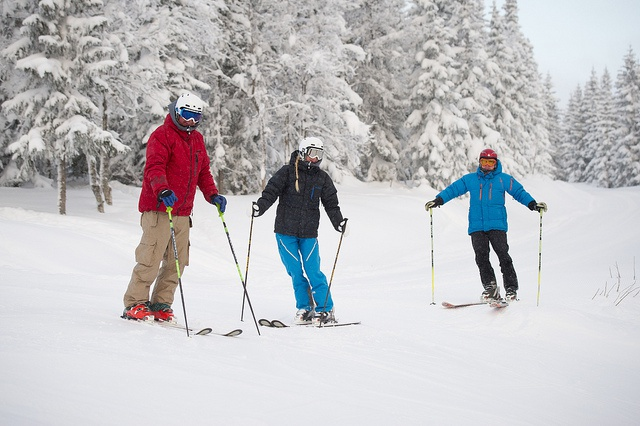Describe the objects in this image and their specific colors. I can see people in darkgray, brown, gray, and maroon tones, people in darkgray, black, teal, and lightgray tones, people in darkgray, teal, black, lightgray, and gray tones, skis in darkgray, lightgray, and gray tones, and skis in darkgray, lightgray, and gray tones in this image. 